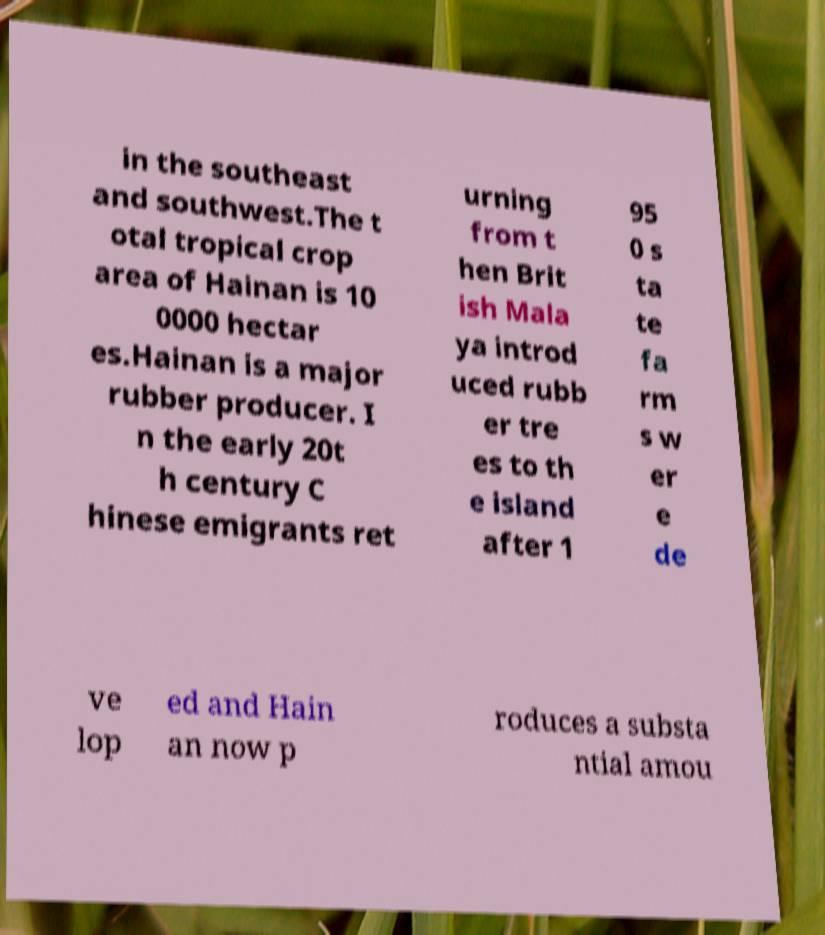Can you accurately transcribe the text from the provided image for me? in the southeast and southwest.The t otal tropical crop area of Hainan is 10 0000 hectar es.Hainan is a major rubber producer. I n the early 20t h century C hinese emigrants ret urning from t hen Brit ish Mala ya introd uced rubb er tre es to th e island after 1 95 0 s ta te fa rm s w er e de ve lop ed and Hain an now p roduces a substa ntial amou 